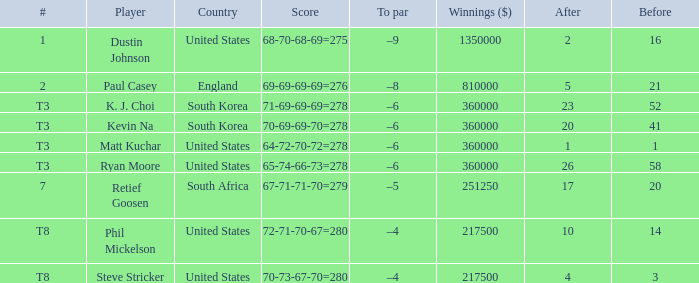What is the total when the competitor is matt kuchar? 64-72-70-72=278. 